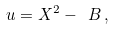Convert formula to latex. <formula><loc_0><loc_0><loc_500><loc_500>u = X ^ { 2 } - \ B \, ,</formula> 